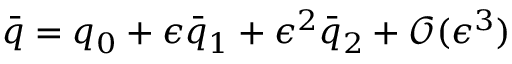Convert formula to latex. <formula><loc_0><loc_0><loc_500><loc_500>\bar { q } = q _ { 0 } + \epsilon \bar { q } _ { 1 } + \epsilon ^ { 2 } \bar { q } _ { 2 } + \mathcal { O } ( \epsilon ^ { 3 } )</formula> 